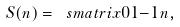Convert formula to latex. <formula><loc_0><loc_0><loc_500><loc_500>S ( n ) = \ s m a t r i x 0 1 { - 1 } n ,</formula> 